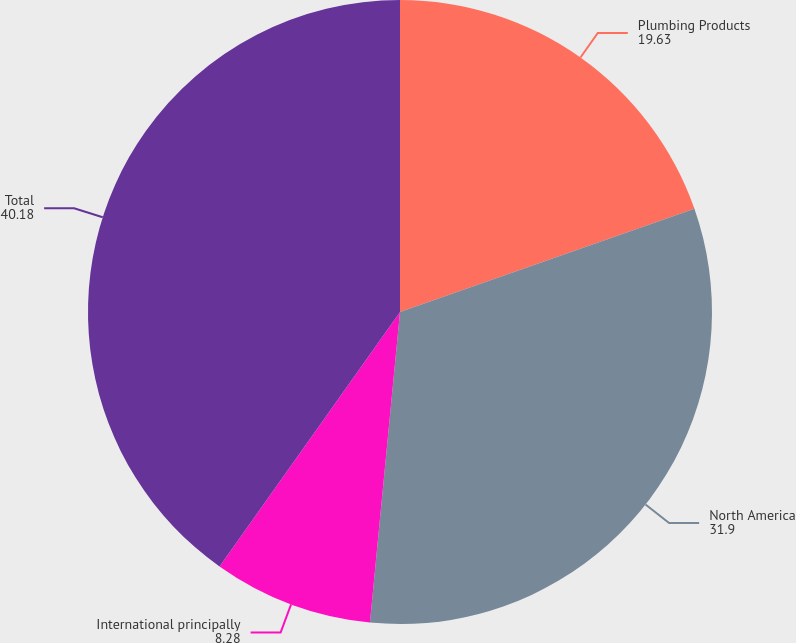<chart> <loc_0><loc_0><loc_500><loc_500><pie_chart><fcel>Plumbing Products<fcel>North America<fcel>International principally<fcel>Total<nl><fcel>19.63%<fcel>31.9%<fcel>8.28%<fcel>40.18%<nl></chart> 